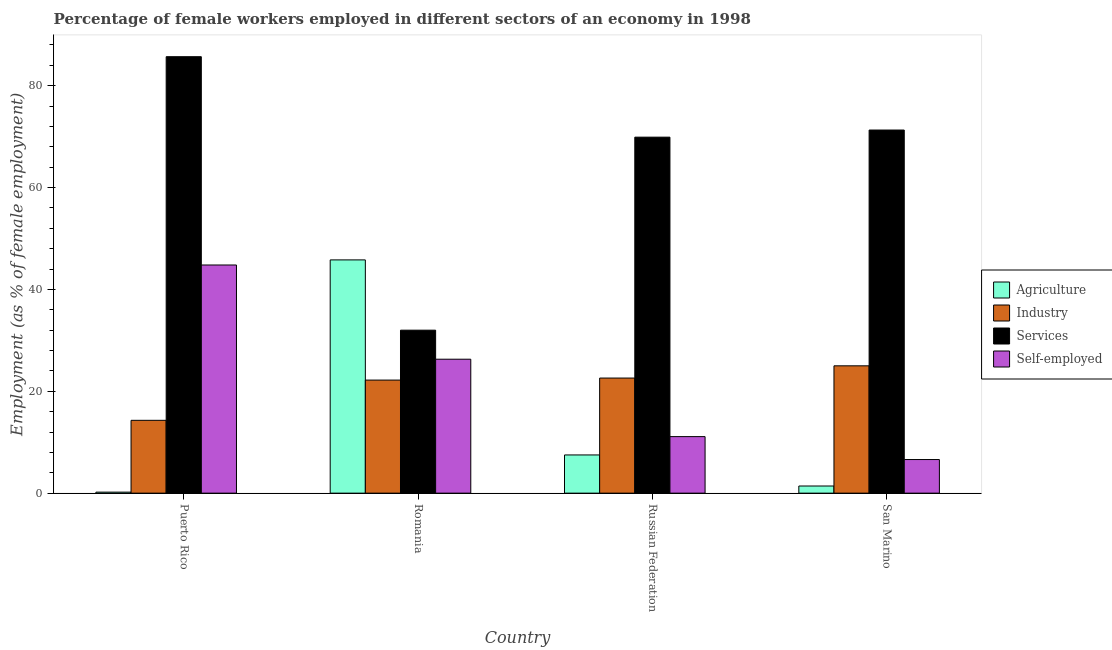How many different coloured bars are there?
Ensure brevity in your answer.  4. Are the number of bars per tick equal to the number of legend labels?
Provide a short and direct response. Yes. How many bars are there on the 2nd tick from the left?
Ensure brevity in your answer.  4. How many bars are there on the 4th tick from the right?
Your answer should be compact. 4. What is the label of the 3rd group of bars from the left?
Your response must be concise. Russian Federation. In how many cases, is the number of bars for a given country not equal to the number of legend labels?
Make the answer very short. 0. What is the percentage of female workers in agriculture in Puerto Rico?
Keep it short and to the point. 0.2. Across all countries, what is the minimum percentage of self employed female workers?
Offer a very short reply. 6.6. In which country was the percentage of self employed female workers maximum?
Offer a very short reply. Puerto Rico. In which country was the percentage of female workers in agriculture minimum?
Your answer should be very brief. Puerto Rico. What is the total percentage of female workers in industry in the graph?
Your answer should be very brief. 84.1. What is the difference between the percentage of female workers in industry in Romania and that in San Marino?
Keep it short and to the point. -2.8. What is the difference between the percentage of female workers in services in Puerto Rico and the percentage of female workers in industry in San Marino?
Provide a short and direct response. 60.7. What is the average percentage of self employed female workers per country?
Provide a short and direct response. 22.2. What is the difference between the percentage of female workers in industry and percentage of female workers in agriculture in Russian Federation?
Provide a succinct answer. 15.1. In how many countries, is the percentage of female workers in agriculture greater than 4 %?
Offer a terse response. 2. What is the ratio of the percentage of female workers in agriculture in Puerto Rico to that in Romania?
Keep it short and to the point. 0. Is the difference between the percentage of female workers in services in Puerto Rico and San Marino greater than the difference between the percentage of self employed female workers in Puerto Rico and San Marino?
Your response must be concise. No. What is the difference between the highest and the second highest percentage of self employed female workers?
Make the answer very short. 18.5. What is the difference between the highest and the lowest percentage of female workers in services?
Give a very brief answer. 53.7. What does the 3rd bar from the left in Russian Federation represents?
Give a very brief answer. Services. What does the 2nd bar from the right in Puerto Rico represents?
Offer a terse response. Services. Is it the case that in every country, the sum of the percentage of female workers in agriculture and percentage of female workers in industry is greater than the percentage of female workers in services?
Your answer should be very brief. No. How many bars are there?
Provide a succinct answer. 16. Are all the bars in the graph horizontal?
Keep it short and to the point. No. Are the values on the major ticks of Y-axis written in scientific E-notation?
Offer a terse response. No. What is the title of the graph?
Give a very brief answer. Percentage of female workers employed in different sectors of an economy in 1998. What is the label or title of the Y-axis?
Your answer should be compact. Employment (as % of female employment). What is the Employment (as % of female employment) of Agriculture in Puerto Rico?
Your response must be concise. 0.2. What is the Employment (as % of female employment) of Industry in Puerto Rico?
Offer a terse response. 14.3. What is the Employment (as % of female employment) in Services in Puerto Rico?
Your response must be concise. 85.7. What is the Employment (as % of female employment) of Self-employed in Puerto Rico?
Keep it short and to the point. 44.8. What is the Employment (as % of female employment) in Agriculture in Romania?
Offer a terse response. 45.8. What is the Employment (as % of female employment) in Industry in Romania?
Your response must be concise. 22.2. What is the Employment (as % of female employment) in Self-employed in Romania?
Provide a short and direct response. 26.3. What is the Employment (as % of female employment) of Agriculture in Russian Federation?
Make the answer very short. 7.5. What is the Employment (as % of female employment) of Industry in Russian Federation?
Keep it short and to the point. 22.6. What is the Employment (as % of female employment) in Services in Russian Federation?
Keep it short and to the point. 69.9. What is the Employment (as % of female employment) of Self-employed in Russian Federation?
Make the answer very short. 11.1. What is the Employment (as % of female employment) in Agriculture in San Marino?
Offer a very short reply. 1.4. What is the Employment (as % of female employment) of Services in San Marino?
Make the answer very short. 71.3. What is the Employment (as % of female employment) of Self-employed in San Marino?
Your response must be concise. 6.6. Across all countries, what is the maximum Employment (as % of female employment) in Agriculture?
Provide a succinct answer. 45.8. Across all countries, what is the maximum Employment (as % of female employment) of Services?
Ensure brevity in your answer.  85.7. Across all countries, what is the maximum Employment (as % of female employment) of Self-employed?
Make the answer very short. 44.8. Across all countries, what is the minimum Employment (as % of female employment) in Agriculture?
Provide a short and direct response. 0.2. Across all countries, what is the minimum Employment (as % of female employment) of Industry?
Your answer should be very brief. 14.3. Across all countries, what is the minimum Employment (as % of female employment) in Services?
Your answer should be compact. 32. Across all countries, what is the minimum Employment (as % of female employment) in Self-employed?
Provide a succinct answer. 6.6. What is the total Employment (as % of female employment) of Agriculture in the graph?
Provide a short and direct response. 54.9. What is the total Employment (as % of female employment) in Industry in the graph?
Offer a very short reply. 84.1. What is the total Employment (as % of female employment) of Services in the graph?
Your response must be concise. 258.9. What is the total Employment (as % of female employment) of Self-employed in the graph?
Give a very brief answer. 88.8. What is the difference between the Employment (as % of female employment) in Agriculture in Puerto Rico and that in Romania?
Offer a very short reply. -45.6. What is the difference between the Employment (as % of female employment) in Industry in Puerto Rico and that in Romania?
Your response must be concise. -7.9. What is the difference between the Employment (as % of female employment) of Services in Puerto Rico and that in Romania?
Your answer should be very brief. 53.7. What is the difference between the Employment (as % of female employment) in Self-employed in Puerto Rico and that in Russian Federation?
Ensure brevity in your answer.  33.7. What is the difference between the Employment (as % of female employment) in Industry in Puerto Rico and that in San Marino?
Offer a very short reply. -10.7. What is the difference between the Employment (as % of female employment) of Services in Puerto Rico and that in San Marino?
Your answer should be very brief. 14.4. What is the difference between the Employment (as % of female employment) of Self-employed in Puerto Rico and that in San Marino?
Your response must be concise. 38.2. What is the difference between the Employment (as % of female employment) in Agriculture in Romania and that in Russian Federation?
Make the answer very short. 38.3. What is the difference between the Employment (as % of female employment) of Industry in Romania and that in Russian Federation?
Give a very brief answer. -0.4. What is the difference between the Employment (as % of female employment) of Services in Romania and that in Russian Federation?
Your answer should be compact. -37.9. What is the difference between the Employment (as % of female employment) of Agriculture in Romania and that in San Marino?
Make the answer very short. 44.4. What is the difference between the Employment (as % of female employment) in Services in Romania and that in San Marino?
Offer a terse response. -39.3. What is the difference between the Employment (as % of female employment) in Agriculture in Russian Federation and that in San Marino?
Provide a short and direct response. 6.1. What is the difference between the Employment (as % of female employment) in Industry in Russian Federation and that in San Marino?
Your answer should be very brief. -2.4. What is the difference between the Employment (as % of female employment) in Self-employed in Russian Federation and that in San Marino?
Your answer should be very brief. 4.5. What is the difference between the Employment (as % of female employment) of Agriculture in Puerto Rico and the Employment (as % of female employment) of Services in Romania?
Provide a succinct answer. -31.8. What is the difference between the Employment (as % of female employment) in Agriculture in Puerto Rico and the Employment (as % of female employment) in Self-employed in Romania?
Your answer should be very brief. -26.1. What is the difference between the Employment (as % of female employment) in Industry in Puerto Rico and the Employment (as % of female employment) in Services in Romania?
Make the answer very short. -17.7. What is the difference between the Employment (as % of female employment) in Services in Puerto Rico and the Employment (as % of female employment) in Self-employed in Romania?
Provide a short and direct response. 59.4. What is the difference between the Employment (as % of female employment) of Agriculture in Puerto Rico and the Employment (as % of female employment) of Industry in Russian Federation?
Offer a terse response. -22.4. What is the difference between the Employment (as % of female employment) in Agriculture in Puerto Rico and the Employment (as % of female employment) in Services in Russian Federation?
Make the answer very short. -69.7. What is the difference between the Employment (as % of female employment) of Industry in Puerto Rico and the Employment (as % of female employment) of Services in Russian Federation?
Make the answer very short. -55.6. What is the difference between the Employment (as % of female employment) in Industry in Puerto Rico and the Employment (as % of female employment) in Self-employed in Russian Federation?
Your response must be concise. 3.2. What is the difference between the Employment (as % of female employment) of Services in Puerto Rico and the Employment (as % of female employment) of Self-employed in Russian Federation?
Provide a succinct answer. 74.6. What is the difference between the Employment (as % of female employment) in Agriculture in Puerto Rico and the Employment (as % of female employment) in Industry in San Marino?
Ensure brevity in your answer.  -24.8. What is the difference between the Employment (as % of female employment) of Agriculture in Puerto Rico and the Employment (as % of female employment) of Services in San Marino?
Offer a terse response. -71.1. What is the difference between the Employment (as % of female employment) of Industry in Puerto Rico and the Employment (as % of female employment) of Services in San Marino?
Provide a short and direct response. -57. What is the difference between the Employment (as % of female employment) in Services in Puerto Rico and the Employment (as % of female employment) in Self-employed in San Marino?
Give a very brief answer. 79.1. What is the difference between the Employment (as % of female employment) in Agriculture in Romania and the Employment (as % of female employment) in Industry in Russian Federation?
Keep it short and to the point. 23.2. What is the difference between the Employment (as % of female employment) in Agriculture in Romania and the Employment (as % of female employment) in Services in Russian Federation?
Your answer should be very brief. -24.1. What is the difference between the Employment (as % of female employment) in Agriculture in Romania and the Employment (as % of female employment) in Self-employed in Russian Federation?
Provide a short and direct response. 34.7. What is the difference between the Employment (as % of female employment) in Industry in Romania and the Employment (as % of female employment) in Services in Russian Federation?
Keep it short and to the point. -47.7. What is the difference between the Employment (as % of female employment) in Industry in Romania and the Employment (as % of female employment) in Self-employed in Russian Federation?
Make the answer very short. 11.1. What is the difference between the Employment (as % of female employment) of Services in Romania and the Employment (as % of female employment) of Self-employed in Russian Federation?
Give a very brief answer. 20.9. What is the difference between the Employment (as % of female employment) in Agriculture in Romania and the Employment (as % of female employment) in Industry in San Marino?
Make the answer very short. 20.8. What is the difference between the Employment (as % of female employment) of Agriculture in Romania and the Employment (as % of female employment) of Services in San Marino?
Provide a short and direct response. -25.5. What is the difference between the Employment (as % of female employment) of Agriculture in Romania and the Employment (as % of female employment) of Self-employed in San Marino?
Give a very brief answer. 39.2. What is the difference between the Employment (as % of female employment) of Industry in Romania and the Employment (as % of female employment) of Services in San Marino?
Your answer should be compact. -49.1. What is the difference between the Employment (as % of female employment) in Industry in Romania and the Employment (as % of female employment) in Self-employed in San Marino?
Your response must be concise. 15.6. What is the difference between the Employment (as % of female employment) in Services in Romania and the Employment (as % of female employment) in Self-employed in San Marino?
Offer a very short reply. 25.4. What is the difference between the Employment (as % of female employment) of Agriculture in Russian Federation and the Employment (as % of female employment) of Industry in San Marino?
Your answer should be compact. -17.5. What is the difference between the Employment (as % of female employment) in Agriculture in Russian Federation and the Employment (as % of female employment) in Services in San Marino?
Make the answer very short. -63.8. What is the difference between the Employment (as % of female employment) of Agriculture in Russian Federation and the Employment (as % of female employment) of Self-employed in San Marino?
Ensure brevity in your answer.  0.9. What is the difference between the Employment (as % of female employment) of Industry in Russian Federation and the Employment (as % of female employment) of Services in San Marino?
Your answer should be very brief. -48.7. What is the difference between the Employment (as % of female employment) of Services in Russian Federation and the Employment (as % of female employment) of Self-employed in San Marino?
Ensure brevity in your answer.  63.3. What is the average Employment (as % of female employment) in Agriculture per country?
Your answer should be compact. 13.72. What is the average Employment (as % of female employment) in Industry per country?
Provide a short and direct response. 21.02. What is the average Employment (as % of female employment) of Services per country?
Your response must be concise. 64.72. What is the difference between the Employment (as % of female employment) in Agriculture and Employment (as % of female employment) in Industry in Puerto Rico?
Offer a very short reply. -14.1. What is the difference between the Employment (as % of female employment) in Agriculture and Employment (as % of female employment) in Services in Puerto Rico?
Give a very brief answer. -85.5. What is the difference between the Employment (as % of female employment) of Agriculture and Employment (as % of female employment) of Self-employed in Puerto Rico?
Offer a very short reply. -44.6. What is the difference between the Employment (as % of female employment) in Industry and Employment (as % of female employment) in Services in Puerto Rico?
Provide a short and direct response. -71.4. What is the difference between the Employment (as % of female employment) in Industry and Employment (as % of female employment) in Self-employed in Puerto Rico?
Provide a short and direct response. -30.5. What is the difference between the Employment (as % of female employment) in Services and Employment (as % of female employment) in Self-employed in Puerto Rico?
Provide a short and direct response. 40.9. What is the difference between the Employment (as % of female employment) in Agriculture and Employment (as % of female employment) in Industry in Romania?
Offer a very short reply. 23.6. What is the difference between the Employment (as % of female employment) in Agriculture and Employment (as % of female employment) in Services in Romania?
Your answer should be compact. 13.8. What is the difference between the Employment (as % of female employment) in Industry and Employment (as % of female employment) in Services in Romania?
Make the answer very short. -9.8. What is the difference between the Employment (as % of female employment) in Industry and Employment (as % of female employment) in Self-employed in Romania?
Keep it short and to the point. -4.1. What is the difference between the Employment (as % of female employment) of Agriculture and Employment (as % of female employment) of Industry in Russian Federation?
Provide a succinct answer. -15.1. What is the difference between the Employment (as % of female employment) in Agriculture and Employment (as % of female employment) in Services in Russian Federation?
Provide a short and direct response. -62.4. What is the difference between the Employment (as % of female employment) of Industry and Employment (as % of female employment) of Services in Russian Federation?
Keep it short and to the point. -47.3. What is the difference between the Employment (as % of female employment) of Industry and Employment (as % of female employment) of Self-employed in Russian Federation?
Give a very brief answer. 11.5. What is the difference between the Employment (as % of female employment) in Services and Employment (as % of female employment) in Self-employed in Russian Federation?
Give a very brief answer. 58.8. What is the difference between the Employment (as % of female employment) of Agriculture and Employment (as % of female employment) of Industry in San Marino?
Provide a succinct answer. -23.6. What is the difference between the Employment (as % of female employment) in Agriculture and Employment (as % of female employment) in Services in San Marino?
Your answer should be very brief. -69.9. What is the difference between the Employment (as % of female employment) in Industry and Employment (as % of female employment) in Services in San Marino?
Offer a terse response. -46.3. What is the difference between the Employment (as % of female employment) in Industry and Employment (as % of female employment) in Self-employed in San Marino?
Provide a short and direct response. 18.4. What is the difference between the Employment (as % of female employment) of Services and Employment (as % of female employment) of Self-employed in San Marino?
Your response must be concise. 64.7. What is the ratio of the Employment (as % of female employment) in Agriculture in Puerto Rico to that in Romania?
Your answer should be very brief. 0. What is the ratio of the Employment (as % of female employment) in Industry in Puerto Rico to that in Romania?
Give a very brief answer. 0.64. What is the ratio of the Employment (as % of female employment) of Services in Puerto Rico to that in Romania?
Keep it short and to the point. 2.68. What is the ratio of the Employment (as % of female employment) in Self-employed in Puerto Rico to that in Romania?
Keep it short and to the point. 1.7. What is the ratio of the Employment (as % of female employment) of Agriculture in Puerto Rico to that in Russian Federation?
Offer a very short reply. 0.03. What is the ratio of the Employment (as % of female employment) of Industry in Puerto Rico to that in Russian Federation?
Your answer should be very brief. 0.63. What is the ratio of the Employment (as % of female employment) of Services in Puerto Rico to that in Russian Federation?
Provide a succinct answer. 1.23. What is the ratio of the Employment (as % of female employment) in Self-employed in Puerto Rico to that in Russian Federation?
Make the answer very short. 4.04. What is the ratio of the Employment (as % of female employment) of Agriculture in Puerto Rico to that in San Marino?
Provide a succinct answer. 0.14. What is the ratio of the Employment (as % of female employment) of Industry in Puerto Rico to that in San Marino?
Make the answer very short. 0.57. What is the ratio of the Employment (as % of female employment) of Services in Puerto Rico to that in San Marino?
Your answer should be compact. 1.2. What is the ratio of the Employment (as % of female employment) in Self-employed in Puerto Rico to that in San Marino?
Your response must be concise. 6.79. What is the ratio of the Employment (as % of female employment) in Agriculture in Romania to that in Russian Federation?
Offer a terse response. 6.11. What is the ratio of the Employment (as % of female employment) of Industry in Romania to that in Russian Federation?
Give a very brief answer. 0.98. What is the ratio of the Employment (as % of female employment) of Services in Romania to that in Russian Federation?
Keep it short and to the point. 0.46. What is the ratio of the Employment (as % of female employment) in Self-employed in Romania to that in Russian Federation?
Your answer should be very brief. 2.37. What is the ratio of the Employment (as % of female employment) of Agriculture in Romania to that in San Marino?
Make the answer very short. 32.71. What is the ratio of the Employment (as % of female employment) in Industry in Romania to that in San Marino?
Offer a terse response. 0.89. What is the ratio of the Employment (as % of female employment) in Services in Romania to that in San Marino?
Your answer should be very brief. 0.45. What is the ratio of the Employment (as % of female employment) in Self-employed in Romania to that in San Marino?
Keep it short and to the point. 3.98. What is the ratio of the Employment (as % of female employment) of Agriculture in Russian Federation to that in San Marino?
Your answer should be compact. 5.36. What is the ratio of the Employment (as % of female employment) of Industry in Russian Federation to that in San Marino?
Offer a terse response. 0.9. What is the ratio of the Employment (as % of female employment) of Services in Russian Federation to that in San Marino?
Your answer should be very brief. 0.98. What is the ratio of the Employment (as % of female employment) of Self-employed in Russian Federation to that in San Marino?
Keep it short and to the point. 1.68. What is the difference between the highest and the second highest Employment (as % of female employment) of Agriculture?
Provide a short and direct response. 38.3. What is the difference between the highest and the second highest Employment (as % of female employment) of Industry?
Your answer should be very brief. 2.4. What is the difference between the highest and the second highest Employment (as % of female employment) of Services?
Your answer should be very brief. 14.4. What is the difference between the highest and the second highest Employment (as % of female employment) in Self-employed?
Make the answer very short. 18.5. What is the difference between the highest and the lowest Employment (as % of female employment) in Agriculture?
Offer a terse response. 45.6. What is the difference between the highest and the lowest Employment (as % of female employment) of Services?
Your answer should be very brief. 53.7. What is the difference between the highest and the lowest Employment (as % of female employment) of Self-employed?
Offer a very short reply. 38.2. 